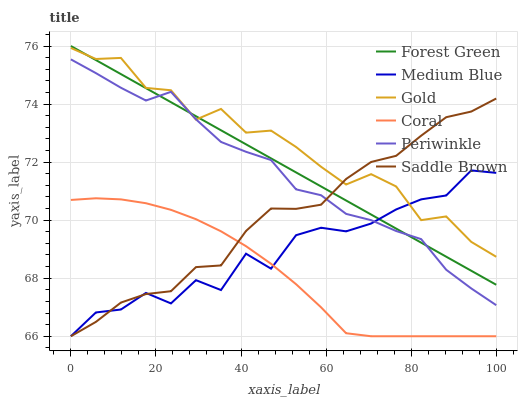Does Coral have the minimum area under the curve?
Answer yes or no. Yes. Does Gold have the maximum area under the curve?
Answer yes or no. Yes. Does Medium Blue have the minimum area under the curve?
Answer yes or no. No. Does Medium Blue have the maximum area under the curve?
Answer yes or no. No. Is Forest Green the smoothest?
Answer yes or no. Yes. Is Medium Blue the roughest?
Answer yes or no. Yes. Is Coral the smoothest?
Answer yes or no. No. Is Coral the roughest?
Answer yes or no. No. Does Coral have the lowest value?
Answer yes or no. Yes. Does Forest Green have the lowest value?
Answer yes or no. No. Does Forest Green have the highest value?
Answer yes or no. Yes. Does Medium Blue have the highest value?
Answer yes or no. No. Is Coral less than Forest Green?
Answer yes or no. Yes. Is Forest Green greater than Coral?
Answer yes or no. Yes. Does Gold intersect Periwinkle?
Answer yes or no. Yes. Is Gold less than Periwinkle?
Answer yes or no. No. Is Gold greater than Periwinkle?
Answer yes or no. No. Does Coral intersect Forest Green?
Answer yes or no. No. 